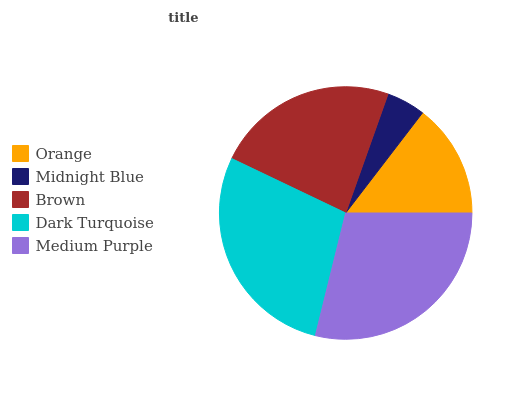Is Midnight Blue the minimum?
Answer yes or no. Yes. Is Medium Purple the maximum?
Answer yes or no. Yes. Is Brown the minimum?
Answer yes or no. No. Is Brown the maximum?
Answer yes or no. No. Is Brown greater than Midnight Blue?
Answer yes or no. Yes. Is Midnight Blue less than Brown?
Answer yes or no. Yes. Is Midnight Blue greater than Brown?
Answer yes or no. No. Is Brown less than Midnight Blue?
Answer yes or no. No. Is Brown the high median?
Answer yes or no. Yes. Is Brown the low median?
Answer yes or no. Yes. Is Medium Purple the high median?
Answer yes or no. No. Is Midnight Blue the low median?
Answer yes or no. No. 